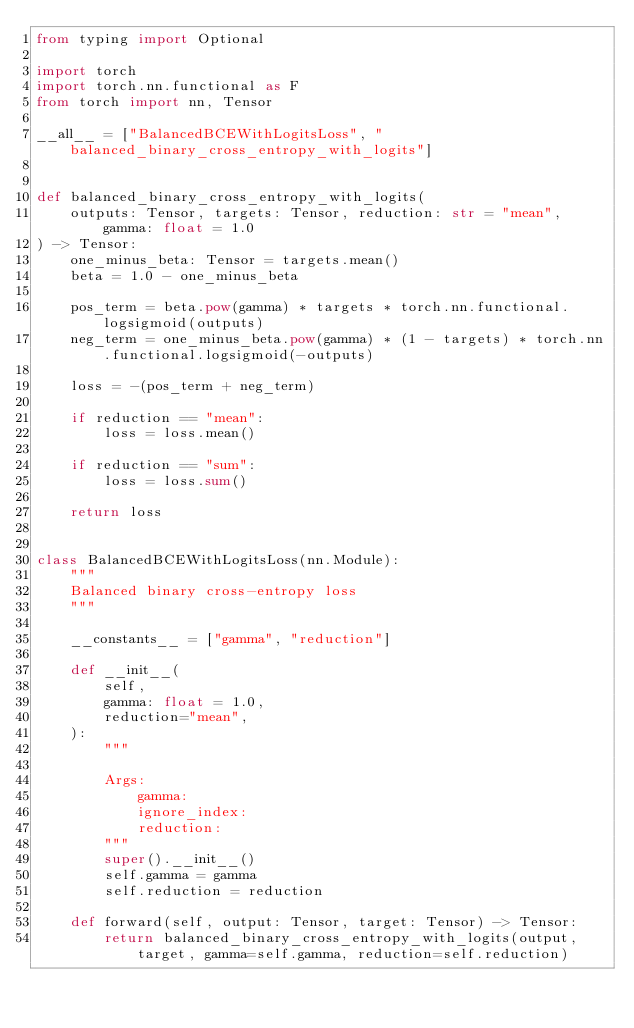Convert code to text. <code><loc_0><loc_0><loc_500><loc_500><_Python_>from typing import Optional

import torch
import torch.nn.functional as F
from torch import nn, Tensor

__all__ = ["BalancedBCEWithLogitsLoss", "balanced_binary_cross_entropy_with_logits"]


def balanced_binary_cross_entropy_with_logits(
    outputs: Tensor, targets: Tensor, reduction: str = "mean", gamma: float = 1.0
) -> Tensor:
    one_minus_beta: Tensor = targets.mean()
    beta = 1.0 - one_minus_beta

    pos_term = beta.pow(gamma) * targets * torch.nn.functional.logsigmoid(outputs)
    neg_term = one_minus_beta.pow(gamma) * (1 - targets) * torch.nn.functional.logsigmoid(-outputs)

    loss = -(pos_term + neg_term)

    if reduction == "mean":
        loss = loss.mean()

    if reduction == "sum":
        loss = loss.sum()

    return loss


class BalancedBCEWithLogitsLoss(nn.Module):
    """
    Balanced binary cross-entropy loss
    """

    __constants__ = ["gamma", "reduction"]

    def __init__(
        self,
        gamma: float = 1.0,
        reduction="mean",
    ):
        """

        Args:
            gamma:
            ignore_index:
            reduction:
        """
        super().__init__()
        self.gamma = gamma
        self.reduction = reduction

    def forward(self, output: Tensor, target: Tensor) -> Tensor:
        return balanced_binary_cross_entropy_with_logits(output, target, gamma=self.gamma, reduction=self.reduction)
</code> 